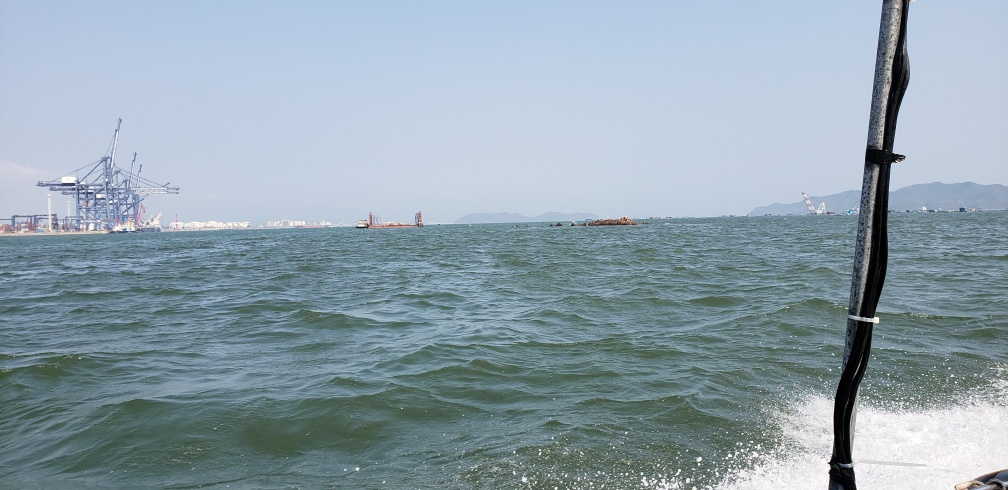Are there any signs of wildlife or natural features? In this image, the focus is primarily on the water and industrial elements on the horizon. There are no immediate signs of wildlife or natural terrestrial features other than the open sea itself. 